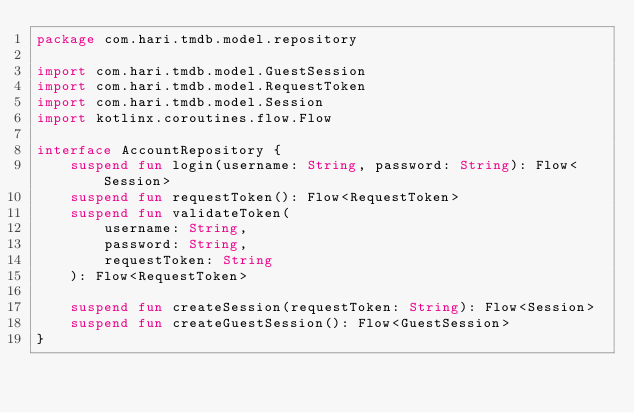Convert code to text. <code><loc_0><loc_0><loc_500><loc_500><_Kotlin_>package com.hari.tmdb.model.repository

import com.hari.tmdb.model.GuestSession
import com.hari.tmdb.model.RequestToken
import com.hari.tmdb.model.Session
import kotlinx.coroutines.flow.Flow

interface AccountRepository {
    suspend fun login(username: String, password: String): Flow<Session>
    suspend fun requestToken(): Flow<RequestToken>
    suspend fun validateToken(
        username: String,
        password: String,
        requestToken: String
    ): Flow<RequestToken>

    suspend fun createSession(requestToken: String): Flow<Session>
    suspend fun createGuestSession(): Flow<GuestSession>
}</code> 